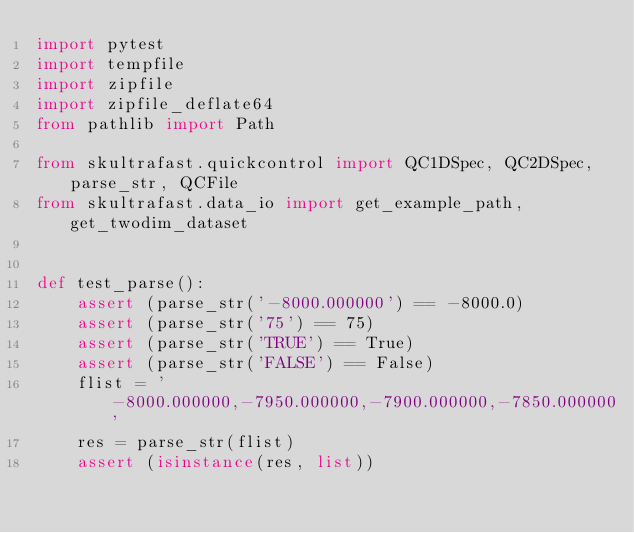<code> <loc_0><loc_0><loc_500><loc_500><_Python_>import pytest
import tempfile
import zipfile
import zipfile_deflate64
from pathlib import Path

from skultrafast.quickcontrol import QC1DSpec, QC2DSpec, parse_str, QCFile
from skultrafast.data_io import get_example_path, get_twodim_dataset


def test_parse():
    assert (parse_str('-8000.000000') == -8000.0)
    assert (parse_str('75') == 75)
    assert (parse_str('TRUE') == True)
    assert (parse_str('FALSE') == False)
    flist = '-8000.000000,-7950.000000,-7900.000000,-7850.000000'
    res = parse_str(flist)
    assert (isinstance(res, list))</code> 